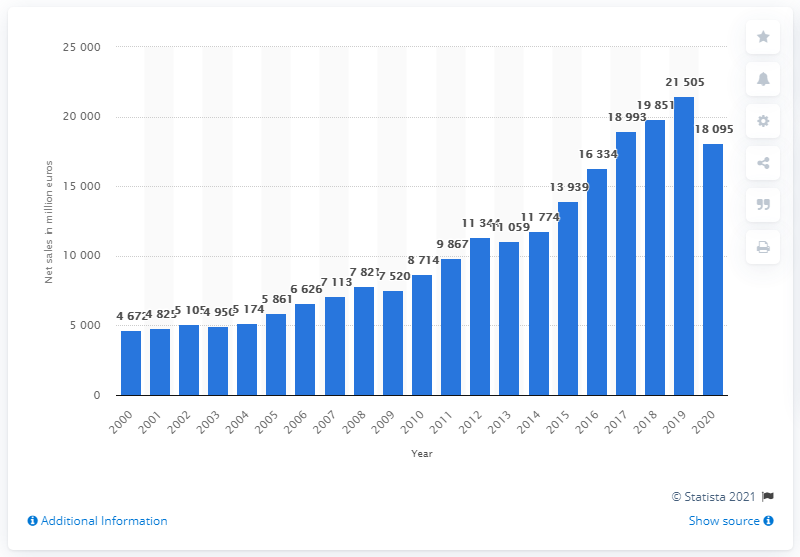Draw attention to some important aspects in this diagram. In 2020, the net sales of the adidas brand amounted to 180,950. 